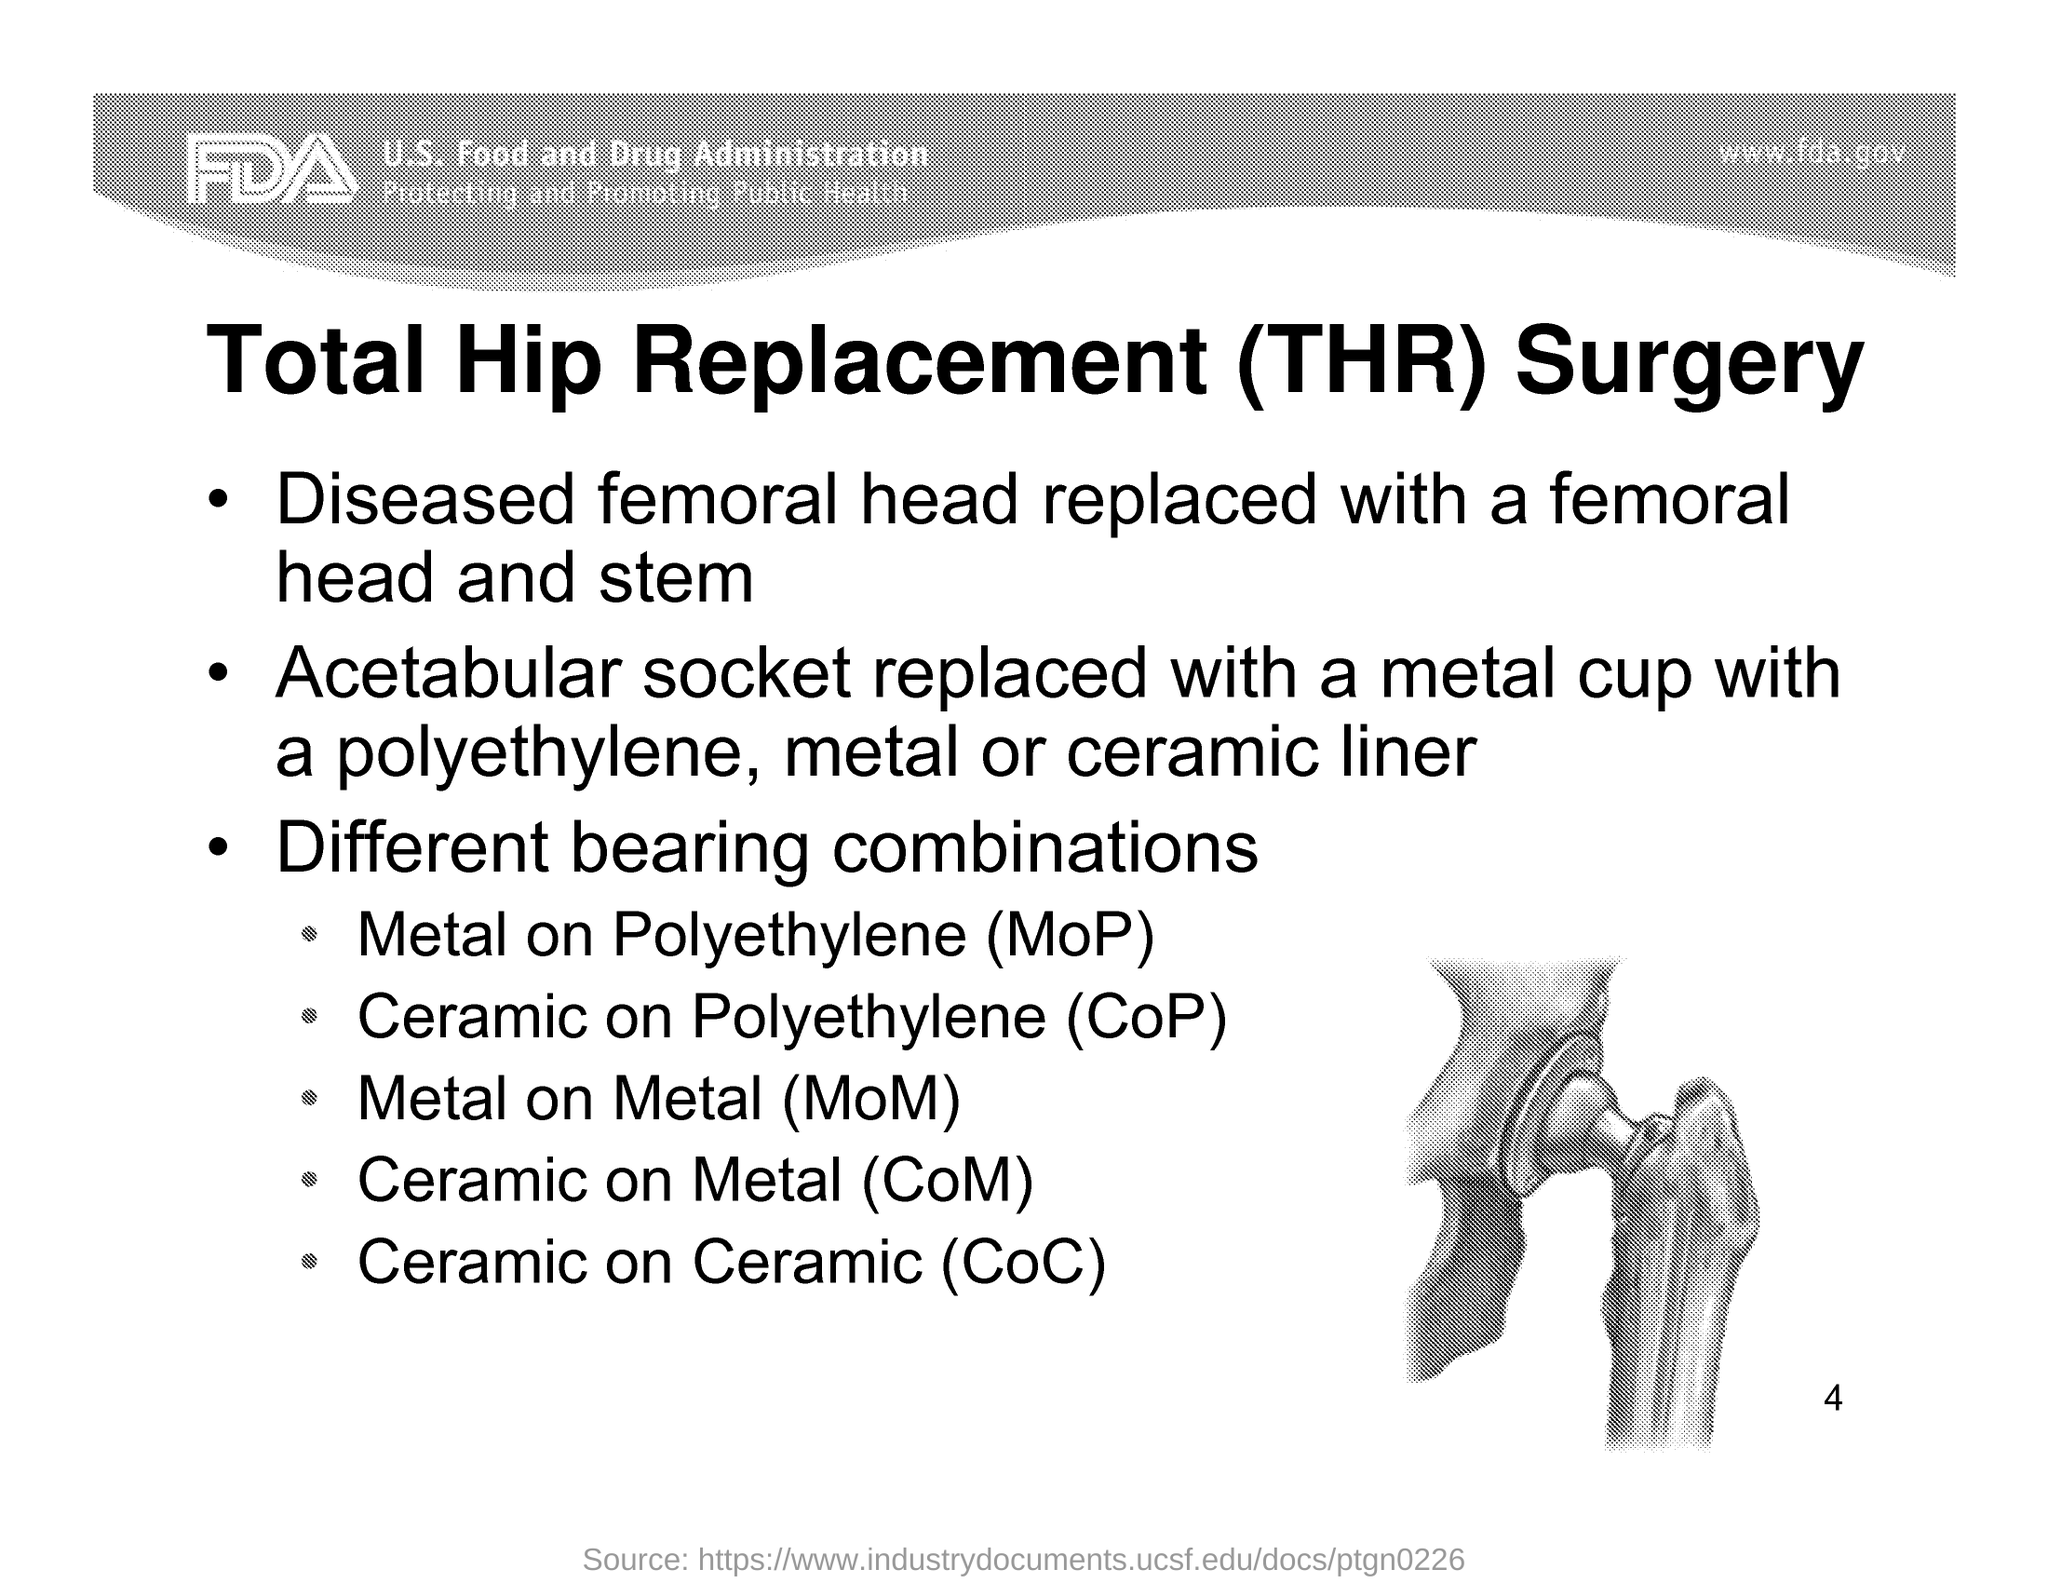What is the Page Number?
Your response must be concise. 4. What is the url mentioned in the document?
Give a very brief answer. Www.fda.gov. 